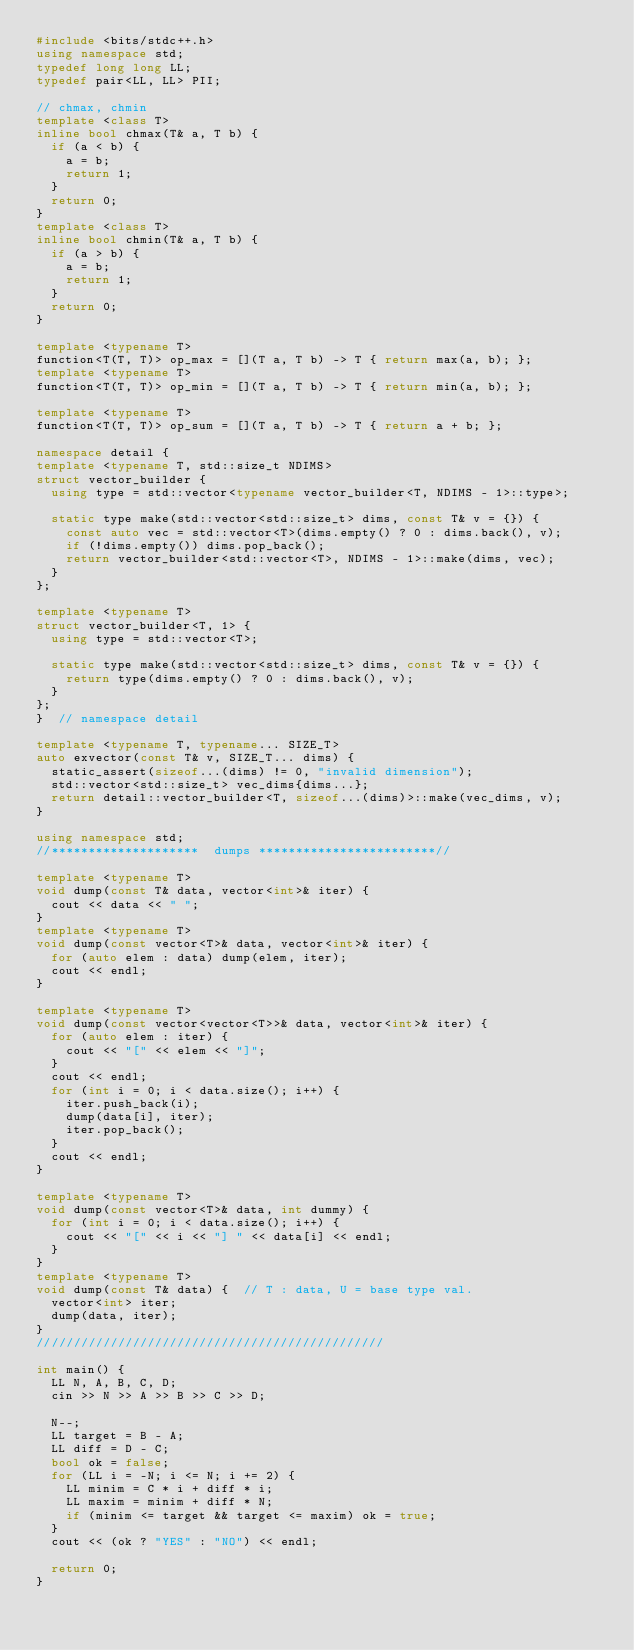Convert code to text. <code><loc_0><loc_0><loc_500><loc_500><_C++_>#include <bits/stdc++.h>
using namespace std;
typedef long long LL;
typedef pair<LL, LL> PII;

// chmax, chmin
template <class T>
inline bool chmax(T& a, T b) {
  if (a < b) {
    a = b;
    return 1;
  }
  return 0;
}
template <class T>
inline bool chmin(T& a, T b) {
  if (a > b) {
    a = b;
    return 1;
  }
  return 0;
}

template <typename T>
function<T(T, T)> op_max = [](T a, T b) -> T { return max(a, b); };
template <typename T>
function<T(T, T)> op_min = [](T a, T b) -> T { return min(a, b); };

template <typename T>
function<T(T, T)> op_sum = [](T a, T b) -> T { return a + b; };

namespace detail {
template <typename T, std::size_t NDIMS>
struct vector_builder {
  using type = std::vector<typename vector_builder<T, NDIMS - 1>::type>;

  static type make(std::vector<std::size_t> dims, const T& v = {}) {
    const auto vec = std::vector<T>(dims.empty() ? 0 : dims.back(), v);
    if (!dims.empty()) dims.pop_back();
    return vector_builder<std::vector<T>, NDIMS - 1>::make(dims, vec);
  }
};

template <typename T>
struct vector_builder<T, 1> {
  using type = std::vector<T>;

  static type make(std::vector<std::size_t> dims, const T& v = {}) {
    return type(dims.empty() ? 0 : dims.back(), v);
  }
};
}  // namespace detail

template <typename T, typename... SIZE_T>
auto exvector(const T& v, SIZE_T... dims) {
  static_assert(sizeof...(dims) != 0, "invalid dimension");
  std::vector<std::size_t> vec_dims{dims...};
  return detail::vector_builder<T, sizeof...(dims)>::make(vec_dims, v);
}

using namespace std;
//********************  dumps ************************//

template <typename T>
void dump(const T& data, vector<int>& iter) {
  cout << data << " ";
}
template <typename T>
void dump(const vector<T>& data, vector<int>& iter) {
  for (auto elem : data) dump(elem, iter);
  cout << endl;
}

template <typename T>
void dump(const vector<vector<T>>& data, vector<int>& iter) {
  for (auto elem : iter) {
    cout << "[" << elem << "]";
  }
  cout << endl;
  for (int i = 0; i < data.size(); i++) {
    iter.push_back(i);
    dump(data[i], iter);
    iter.pop_back();
  }
  cout << endl;
}

template <typename T>
void dump(const vector<T>& data, int dummy) {
  for (int i = 0; i < data.size(); i++) {
    cout << "[" << i << "] " << data[i] << endl;
  }
}
template <typename T>
void dump(const T& data) {  // T : data, U = base type val.
  vector<int> iter;
  dump(data, iter);
}
///////////////////////////////////////////////

int main() {
  LL N, A, B, C, D;
  cin >> N >> A >> B >> C >> D;

  N--;
  LL target = B - A;
  LL diff = D - C;
  bool ok = false;
  for (LL i = -N; i <= N; i += 2) {
    LL minim = C * i + diff * i;
    LL maxim = minim + diff * N;
    if (minim <= target && target <= maxim) ok = true;
  }
  cout << (ok ? "YES" : "NO") << endl;

  return 0;
}
</code> 